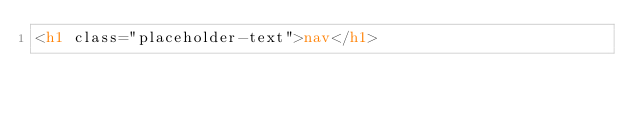<code> <loc_0><loc_0><loc_500><loc_500><_HTML_><h1 class="placeholder-text">nav</h1></code> 